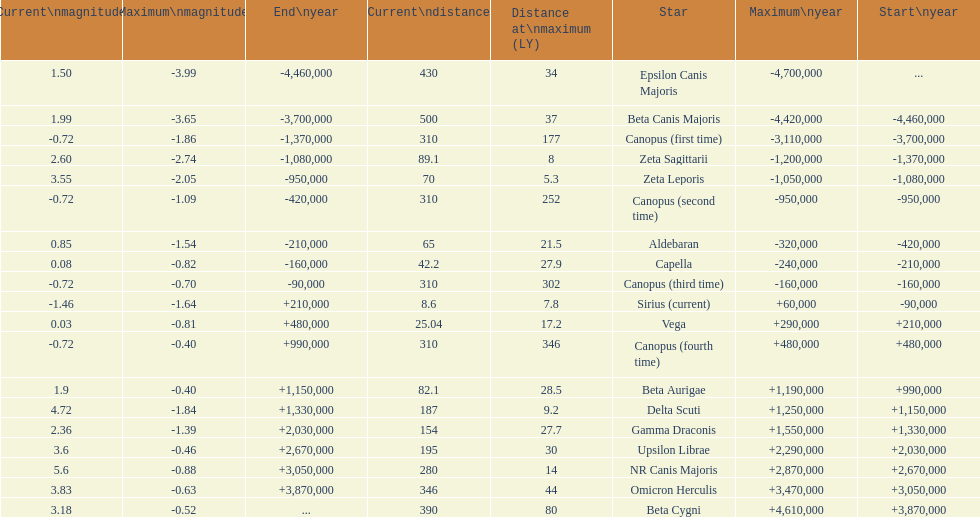What is the difference in the nearest current distance and farthest current distance? 491.4. 